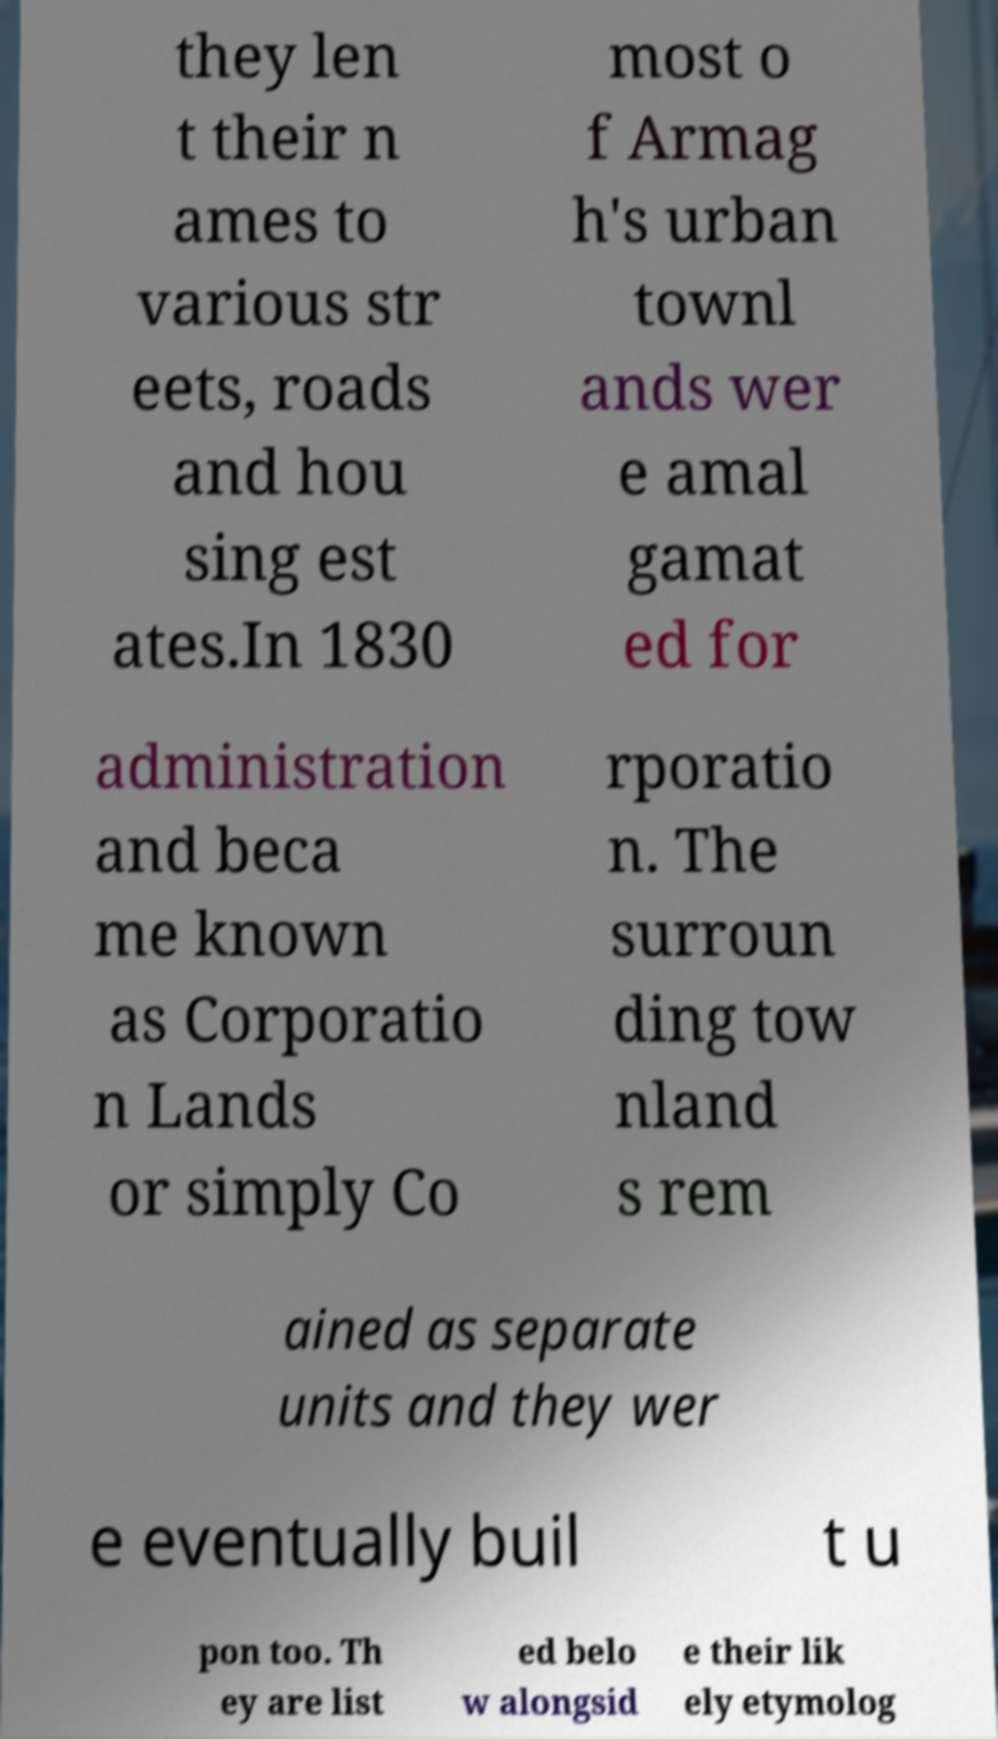What messages or text are displayed in this image? I need them in a readable, typed format. they len t their n ames to various str eets, roads and hou sing est ates.In 1830 most o f Armag h's urban townl ands wer e amal gamat ed for administration and beca me known as Corporatio n Lands or simply Co rporatio n. The surroun ding tow nland s rem ained as separate units and they wer e eventually buil t u pon too. Th ey are list ed belo w alongsid e their lik ely etymolog 